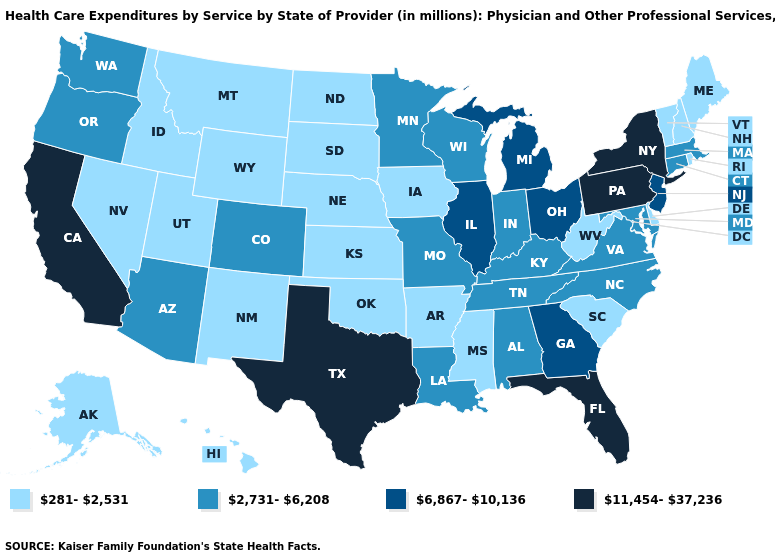Does Virginia have the lowest value in the South?
Short answer required. No. Does Illinois have a lower value than Oklahoma?
Answer briefly. No. Name the states that have a value in the range 2,731-6,208?
Keep it brief. Alabama, Arizona, Colorado, Connecticut, Indiana, Kentucky, Louisiana, Maryland, Massachusetts, Minnesota, Missouri, North Carolina, Oregon, Tennessee, Virginia, Washington, Wisconsin. What is the value of Kentucky?
Answer briefly. 2,731-6,208. Name the states that have a value in the range 281-2,531?
Concise answer only. Alaska, Arkansas, Delaware, Hawaii, Idaho, Iowa, Kansas, Maine, Mississippi, Montana, Nebraska, Nevada, New Hampshire, New Mexico, North Dakota, Oklahoma, Rhode Island, South Carolina, South Dakota, Utah, Vermont, West Virginia, Wyoming. Which states have the lowest value in the MidWest?
Keep it brief. Iowa, Kansas, Nebraska, North Dakota, South Dakota. Among the states that border Massachusetts , which have the highest value?
Keep it brief. New York. Name the states that have a value in the range 11,454-37,236?
Answer briefly. California, Florida, New York, Pennsylvania, Texas. What is the value of Montana?
Concise answer only. 281-2,531. Does California have the highest value in the West?
Be succinct. Yes. Does the first symbol in the legend represent the smallest category?
Keep it brief. Yes. Name the states that have a value in the range 11,454-37,236?
Give a very brief answer. California, Florida, New York, Pennsylvania, Texas. Which states have the lowest value in the Northeast?
Concise answer only. Maine, New Hampshire, Rhode Island, Vermont. Which states have the lowest value in the USA?
Give a very brief answer. Alaska, Arkansas, Delaware, Hawaii, Idaho, Iowa, Kansas, Maine, Mississippi, Montana, Nebraska, Nevada, New Hampshire, New Mexico, North Dakota, Oklahoma, Rhode Island, South Carolina, South Dakota, Utah, Vermont, West Virginia, Wyoming. Does New Mexico have the lowest value in the USA?
Answer briefly. Yes. 